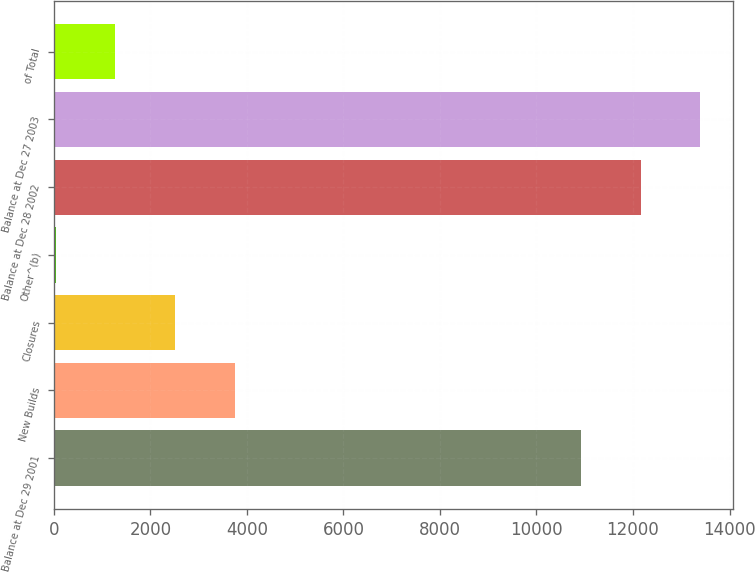Convert chart to OTSL. <chart><loc_0><loc_0><loc_500><loc_500><bar_chart><fcel>Balance at Dec 29 2001<fcel>New Builds<fcel>Closures<fcel>Other^(b)<fcel>Balance at Dec 28 2002<fcel>Balance at Dec 27 2003<fcel>of Total<nl><fcel>10927<fcel>3742.5<fcel>2509<fcel>42<fcel>12160.5<fcel>13394<fcel>1275.5<nl></chart> 